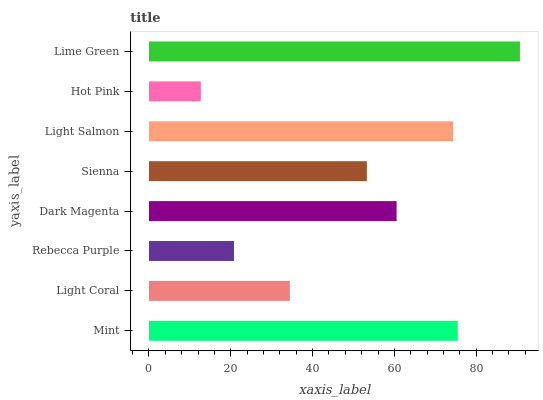Is Hot Pink the minimum?
Answer yes or no. Yes. Is Lime Green the maximum?
Answer yes or no. Yes. Is Light Coral the minimum?
Answer yes or no. No. Is Light Coral the maximum?
Answer yes or no. No. Is Mint greater than Light Coral?
Answer yes or no. Yes. Is Light Coral less than Mint?
Answer yes or no. Yes. Is Light Coral greater than Mint?
Answer yes or no. No. Is Mint less than Light Coral?
Answer yes or no. No. Is Dark Magenta the high median?
Answer yes or no. Yes. Is Sienna the low median?
Answer yes or no. Yes. Is Light Coral the high median?
Answer yes or no. No. Is Mint the low median?
Answer yes or no. No. 